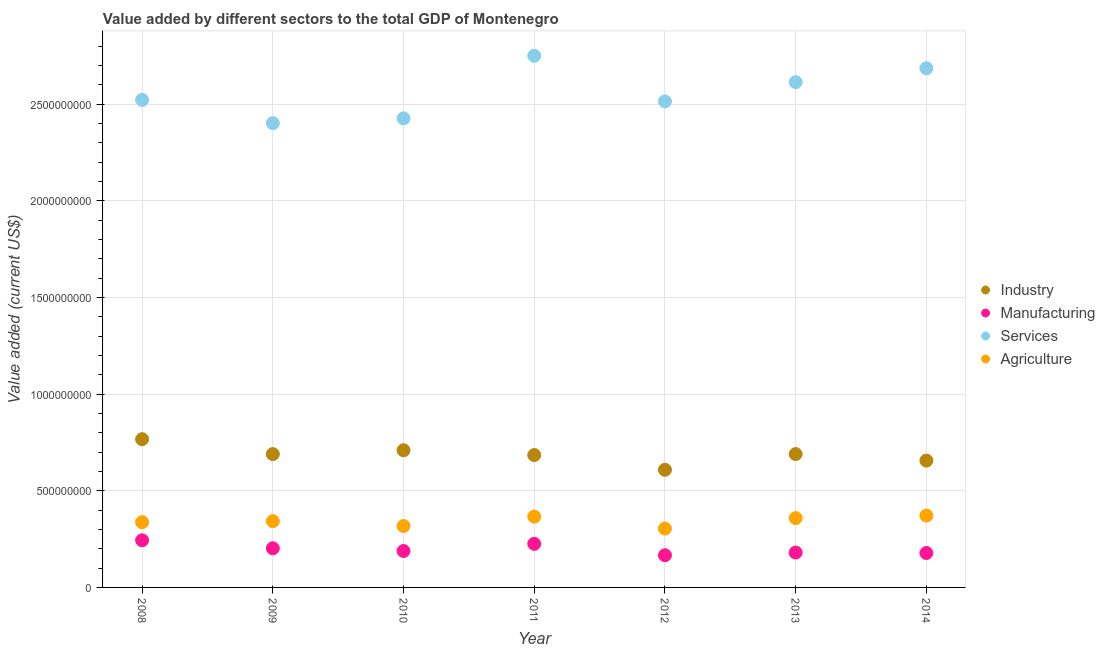How many different coloured dotlines are there?
Ensure brevity in your answer.  4. What is the value added by services sector in 2014?
Make the answer very short. 2.69e+09. Across all years, what is the maximum value added by industrial sector?
Ensure brevity in your answer.  7.67e+08. Across all years, what is the minimum value added by agricultural sector?
Your response must be concise. 3.05e+08. In which year was the value added by industrial sector maximum?
Provide a succinct answer. 2008. What is the total value added by services sector in the graph?
Ensure brevity in your answer.  1.79e+1. What is the difference between the value added by agricultural sector in 2009 and that in 2014?
Make the answer very short. -2.87e+07. What is the difference between the value added by manufacturing sector in 2014 and the value added by industrial sector in 2008?
Provide a short and direct response. -5.89e+08. What is the average value added by manufacturing sector per year?
Keep it short and to the point. 1.98e+08. In the year 2008, what is the difference between the value added by manufacturing sector and value added by industrial sector?
Your answer should be compact. -5.23e+08. In how many years, is the value added by services sector greater than 100000000 US$?
Provide a short and direct response. 7. What is the ratio of the value added by services sector in 2013 to that in 2014?
Offer a terse response. 0.97. What is the difference between the highest and the second highest value added by services sector?
Offer a very short reply. 6.45e+07. What is the difference between the highest and the lowest value added by industrial sector?
Provide a succinct answer. 1.59e+08. In how many years, is the value added by agricultural sector greater than the average value added by agricultural sector taken over all years?
Give a very brief answer. 4. Is the sum of the value added by services sector in 2008 and 2012 greater than the maximum value added by agricultural sector across all years?
Provide a short and direct response. Yes. Is it the case that in every year, the sum of the value added by industrial sector and value added by manufacturing sector is greater than the value added by services sector?
Your answer should be very brief. No. Does the value added by services sector monotonically increase over the years?
Make the answer very short. No. How many years are there in the graph?
Offer a terse response. 7. Does the graph contain grids?
Offer a very short reply. Yes. How many legend labels are there?
Provide a succinct answer. 4. How are the legend labels stacked?
Offer a very short reply. Vertical. What is the title of the graph?
Offer a terse response. Value added by different sectors to the total GDP of Montenegro. What is the label or title of the Y-axis?
Ensure brevity in your answer.  Value added (current US$). What is the Value added (current US$) of Industry in 2008?
Keep it short and to the point. 7.67e+08. What is the Value added (current US$) of Manufacturing in 2008?
Offer a terse response. 2.44e+08. What is the Value added (current US$) in Services in 2008?
Offer a very short reply. 2.52e+09. What is the Value added (current US$) of Agriculture in 2008?
Provide a succinct answer. 3.38e+08. What is the Value added (current US$) of Industry in 2009?
Offer a terse response. 6.90e+08. What is the Value added (current US$) of Manufacturing in 2009?
Offer a very short reply. 2.03e+08. What is the Value added (current US$) of Services in 2009?
Your answer should be compact. 2.40e+09. What is the Value added (current US$) in Agriculture in 2009?
Your answer should be very brief. 3.43e+08. What is the Value added (current US$) in Industry in 2010?
Offer a terse response. 7.10e+08. What is the Value added (current US$) of Manufacturing in 2010?
Ensure brevity in your answer.  1.88e+08. What is the Value added (current US$) in Services in 2010?
Offer a terse response. 2.43e+09. What is the Value added (current US$) in Agriculture in 2010?
Offer a very short reply. 3.18e+08. What is the Value added (current US$) of Industry in 2011?
Ensure brevity in your answer.  6.85e+08. What is the Value added (current US$) in Manufacturing in 2011?
Your answer should be compact. 2.26e+08. What is the Value added (current US$) of Services in 2011?
Keep it short and to the point. 2.75e+09. What is the Value added (current US$) of Agriculture in 2011?
Provide a short and direct response. 3.66e+08. What is the Value added (current US$) of Industry in 2012?
Your answer should be compact. 6.09e+08. What is the Value added (current US$) of Manufacturing in 2012?
Keep it short and to the point. 1.67e+08. What is the Value added (current US$) of Services in 2012?
Ensure brevity in your answer.  2.51e+09. What is the Value added (current US$) in Agriculture in 2012?
Provide a succinct answer. 3.05e+08. What is the Value added (current US$) of Industry in 2013?
Your response must be concise. 6.90e+08. What is the Value added (current US$) of Manufacturing in 2013?
Your answer should be very brief. 1.80e+08. What is the Value added (current US$) in Services in 2013?
Keep it short and to the point. 2.61e+09. What is the Value added (current US$) of Agriculture in 2013?
Provide a succinct answer. 3.59e+08. What is the Value added (current US$) of Industry in 2014?
Give a very brief answer. 6.56e+08. What is the Value added (current US$) of Manufacturing in 2014?
Your answer should be compact. 1.78e+08. What is the Value added (current US$) in Services in 2014?
Your answer should be very brief. 2.69e+09. What is the Value added (current US$) of Agriculture in 2014?
Your response must be concise. 3.72e+08. Across all years, what is the maximum Value added (current US$) of Industry?
Ensure brevity in your answer.  7.67e+08. Across all years, what is the maximum Value added (current US$) of Manufacturing?
Your answer should be compact. 2.44e+08. Across all years, what is the maximum Value added (current US$) of Services?
Make the answer very short. 2.75e+09. Across all years, what is the maximum Value added (current US$) of Agriculture?
Provide a short and direct response. 3.72e+08. Across all years, what is the minimum Value added (current US$) in Industry?
Provide a short and direct response. 6.09e+08. Across all years, what is the minimum Value added (current US$) in Manufacturing?
Offer a very short reply. 1.67e+08. Across all years, what is the minimum Value added (current US$) in Services?
Keep it short and to the point. 2.40e+09. Across all years, what is the minimum Value added (current US$) in Agriculture?
Your answer should be compact. 3.05e+08. What is the total Value added (current US$) of Industry in the graph?
Provide a short and direct response. 4.81e+09. What is the total Value added (current US$) in Manufacturing in the graph?
Offer a terse response. 1.39e+09. What is the total Value added (current US$) in Services in the graph?
Offer a terse response. 1.79e+1. What is the total Value added (current US$) in Agriculture in the graph?
Your response must be concise. 2.40e+09. What is the difference between the Value added (current US$) of Industry in 2008 and that in 2009?
Keep it short and to the point. 7.74e+07. What is the difference between the Value added (current US$) of Manufacturing in 2008 and that in 2009?
Give a very brief answer. 4.13e+07. What is the difference between the Value added (current US$) in Services in 2008 and that in 2009?
Ensure brevity in your answer.  1.20e+08. What is the difference between the Value added (current US$) of Agriculture in 2008 and that in 2009?
Ensure brevity in your answer.  -5.26e+06. What is the difference between the Value added (current US$) in Industry in 2008 and that in 2010?
Keep it short and to the point. 5.74e+07. What is the difference between the Value added (current US$) of Manufacturing in 2008 and that in 2010?
Your response must be concise. 5.54e+07. What is the difference between the Value added (current US$) in Services in 2008 and that in 2010?
Offer a terse response. 9.55e+07. What is the difference between the Value added (current US$) in Agriculture in 2008 and that in 2010?
Your answer should be very brief. 1.98e+07. What is the difference between the Value added (current US$) in Industry in 2008 and that in 2011?
Your response must be concise. 8.22e+07. What is the difference between the Value added (current US$) of Manufacturing in 2008 and that in 2011?
Give a very brief answer. 1.82e+07. What is the difference between the Value added (current US$) in Services in 2008 and that in 2011?
Ensure brevity in your answer.  -2.28e+08. What is the difference between the Value added (current US$) in Agriculture in 2008 and that in 2011?
Offer a terse response. -2.87e+07. What is the difference between the Value added (current US$) in Industry in 2008 and that in 2012?
Ensure brevity in your answer.  1.59e+08. What is the difference between the Value added (current US$) of Manufacturing in 2008 and that in 2012?
Your answer should be compact. 7.72e+07. What is the difference between the Value added (current US$) of Services in 2008 and that in 2012?
Your answer should be very brief. 7.86e+06. What is the difference between the Value added (current US$) in Agriculture in 2008 and that in 2012?
Your answer should be very brief. 3.30e+07. What is the difference between the Value added (current US$) in Industry in 2008 and that in 2013?
Offer a very short reply. 7.71e+07. What is the difference between the Value added (current US$) of Manufacturing in 2008 and that in 2013?
Make the answer very short. 6.33e+07. What is the difference between the Value added (current US$) in Services in 2008 and that in 2013?
Keep it short and to the point. -9.17e+07. What is the difference between the Value added (current US$) in Agriculture in 2008 and that in 2013?
Make the answer very short. -2.11e+07. What is the difference between the Value added (current US$) in Industry in 2008 and that in 2014?
Your answer should be very brief. 1.11e+08. What is the difference between the Value added (current US$) in Manufacturing in 2008 and that in 2014?
Offer a terse response. 6.58e+07. What is the difference between the Value added (current US$) in Services in 2008 and that in 2014?
Provide a succinct answer. -1.64e+08. What is the difference between the Value added (current US$) of Agriculture in 2008 and that in 2014?
Your answer should be compact. -3.40e+07. What is the difference between the Value added (current US$) of Industry in 2009 and that in 2010?
Ensure brevity in your answer.  -2.00e+07. What is the difference between the Value added (current US$) of Manufacturing in 2009 and that in 2010?
Provide a short and direct response. 1.41e+07. What is the difference between the Value added (current US$) in Services in 2009 and that in 2010?
Give a very brief answer. -2.50e+07. What is the difference between the Value added (current US$) in Agriculture in 2009 and that in 2010?
Provide a succinct answer. 2.51e+07. What is the difference between the Value added (current US$) in Industry in 2009 and that in 2011?
Your answer should be compact. 4.80e+06. What is the difference between the Value added (current US$) of Manufacturing in 2009 and that in 2011?
Your answer should be compact. -2.31e+07. What is the difference between the Value added (current US$) of Services in 2009 and that in 2011?
Offer a terse response. -3.49e+08. What is the difference between the Value added (current US$) of Agriculture in 2009 and that in 2011?
Provide a succinct answer. -2.35e+07. What is the difference between the Value added (current US$) in Industry in 2009 and that in 2012?
Provide a succinct answer. 8.11e+07. What is the difference between the Value added (current US$) of Manufacturing in 2009 and that in 2012?
Your answer should be compact. 3.59e+07. What is the difference between the Value added (current US$) of Services in 2009 and that in 2012?
Make the answer very short. -1.13e+08. What is the difference between the Value added (current US$) in Agriculture in 2009 and that in 2012?
Provide a succinct answer. 3.83e+07. What is the difference between the Value added (current US$) in Industry in 2009 and that in 2013?
Offer a terse response. -2.49e+05. What is the difference between the Value added (current US$) in Manufacturing in 2009 and that in 2013?
Offer a terse response. 2.21e+07. What is the difference between the Value added (current US$) of Services in 2009 and that in 2013?
Make the answer very short. -2.12e+08. What is the difference between the Value added (current US$) in Agriculture in 2009 and that in 2013?
Provide a short and direct response. -1.58e+07. What is the difference between the Value added (current US$) of Industry in 2009 and that in 2014?
Offer a terse response. 3.36e+07. What is the difference between the Value added (current US$) in Manufacturing in 2009 and that in 2014?
Make the answer very short. 2.45e+07. What is the difference between the Value added (current US$) in Services in 2009 and that in 2014?
Your answer should be compact. -2.84e+08. What is the difference between the Value added (current US$) in Agriculture in 2009 and that in 2014?
Give a very brief answer. -2.87e+07. What is the difference between the Value added (current US$) of Industry in 2010 and that in 2011?
Keep it short and to the point. 2.48e+07. What is the difference between the Value added (current US$) of Manufacturing in 2010 and that in 2011?
Your answer should be compact. -3.72e+07. What is the difference between the Value added (current US$) of Services in 2010 and that in 2011?
Make the answer very short. -3.24e+08. What is the difference between the Value added (current US$) of Agriculture in 2010 and that in 2011?
Give a very brief answer. -4.86e+07. What is the difference between the Value added (current US$) in Industry in 2010 and that in 2012?
Make the answer very short. 1.01e+08. What is the difference between the Value added (current US$) of Manufacturing in 2010 and that in 2012?
Your answer should be compact. 2.18e+07. What is the difference between the Value added (current US$) of Services in 2010 and that in 2012?
Provide a succinct answer. -8.77e+07. What is the difference between the Value added (current US$) in Agriculture in 2010 and that in 2012?
Provide a short and direct response. 1.32e+07. What is the difference between the Value added (current US$) of Industry in 2010 and that in 2013?
Your answer should be compact. 1.98e+07. What is the difference between the Value added (current US$) of Manufacturing in 2010 and that in 2013?
Offer a very short reply. 7.96e+06. What is the difference between the Value added (current US$) in Services in 2010 and that in 2013?
Give a very brief answer. -1.87e+08. What is the difference between the Value added (current US$) of Agriculture in 2010 and that in 2013?
Ensure brevity in your answer.  -4.09e+07. What is the difference between the Value added (current US$) in Industry in 2010 and that in 2014?
Provide a succinct answer. 5.36e+07. What is the difference between the Value added (current US$) in Manufacturing in 2010 and that in 2014?
Offer a terse response. 1.04e+07. What is the difference between the Value added (current US$) in Services in 2010 and that in 2014?
Give a very brief answer. -2.59e+08. What is the difference between the Value added (current US$) in Agriculture in 2010 and that in 2014?
Make the answer very short. -5.38e+07. What is the difference between the Value added (current US$) in Industry in 2011 and that in 2012?
Your answer should be compact. 7.63e+07. What is the difference between the Value added (current US$) in Manufacturing in 2011 and that in 2012?
Make the answer very short. 5.90e+07. What is the difference between the Value added (current US$) in Services in 2011 and that in 2012?
Provide a succinct answer. 2.36e+08. What is the difference between the Value added (current US$) in Agriculture in 2011 and that in 2012?
Provide a succinct answer. 6.17e+07. What is the difference between the Value added (current US$) in Industry in 2011 and that in 2013?
Provide a succinct answer. -5.05e+06. What is the difference between the Value added (current US$) of Manufacturing in 2011 and that in 2013?
Keep it short and to the point. 4.51e+07. What is the difference between the Value added (current US$) in Services in 2011 and that in 2013?
Make the answer very short. 1.36e+08. What is the difference between the Value added (current US$) in Agriculture in 2011 and that in 2013?
Ensure brevity in your answer.  7.68e+06. What is the difference between the Value added (current US$) of Industry in 2011 and that in 2014?
Your answer should be compact. 2.88e+07. What is the difference between the Value added (current US$) in Manufacturing in 2011 and that in 2014?
Keep it short and to the point. 4.76e+07. What is the difference between the Value added (current US$) in Services in 2011 and that in 2014?
Offer a terse response. 6.45e+07. What is the difference between the Value added (current US$) in Agriculture in 2011 and that in 2014?
Provide a succinct answer. -5.25e+06. What is the difference between the Value added (current US$) of Industry in 2012 and that in 2013?
Ensure brevity in your answer.  -8.14e+07. What is the difference between the Value added (current US$) in Manufacturing in 2012 and that in 2013?
Keep it short and to the point. -1.39e+07. What is the difference between the Value added (current US$) in Services in 2012 and that in 2013?
Give a very brief answer. -9.96e+07. What is the difference between the Value added (current US$) of Agriculture in 2012 and that in 2013?
Your answer should be very brief. -5.41e+07. What is the difference between the Value added (current US$) of Industry in 2012 and that in 2014?
Your response must be concise. -4.76e+07. What is the difference between the Value added (current US$) in Manufacturing in 2012 and that in 2014?
Your answer should be compact. -1.14e+07. What is the difference between the Value added (current US$) of Services in 2012 and that in 2014?
Give a very brief answer. -1.71e+08. What is the difference between the Value added (current US$) in Agriculture in 2012 and that in 2014?
Provide a succinct answer. -6.70e+07. What is the difference between the Value added (current US$) of Industry in 2013 and that in 2014?
Make the answer very short. 3.38e+07. What is the difference between the Value added (current US$) of Manufacturing in 2013 and that in 2014?
Offer a terse response. 2.48e+06. What is the difference between the Value added (current US$) of Services in 2013 and that in 2014?
Give a very brief answer. -7.19e+07. What is the difference between the Value added (current US$) in Agriculture in 2013 and that in 2014?
Offer a terse response. -1.29e+07. What is the difference between the Value added (current US$) in Industry in 2008 and the Value added (current US$) in Manufacturing in 2009?
Provide a short and direct response. 5.65e+08. What is the difference between the Value added (current US$) in Industry in 2008 and the Value added (current US$) in Services in 2009?
Your answer should be compact. -1.64e+09. What is the difference between the Value added (current US$) in Industry in 2008 and the Value added (current US$) in Agriculture in 2009?
Give a very brief answer. 4.24e+08. What is the difference between the Value added (current US$) of Manufacturing in 2008 and the Value added (current US$) of Services in 2009?
Offer a terse response. -2.16e+09. What is the difference between the Value added (current US$) of Manufacturing in 2008 and the Value added (current US$) of Agriculture in 2009?
Your answer should be very brief. -9.90e+07. What is the difference between the Value added (current US$) in Services in 2008 and the Value added (current US$) in Agriculture in 2009?
Ensure brevity in your answer.  2.18e+09. What is the difference between the Value added (current US$) of Industry in 2008 and the Value added (current US$) of Manufacturing in 2010?
Your answer should be very brief. 5.79e+08. What is the difference between the Value added (current US$) in Industry in 2008 and the Value added (current US$) in Services in 2010?
Ensure brevity in your answer.  -1.66e+09. What is the difference between the Value added (current US$) of Industry in 2008 and the Value added (current US$) of Agriculture in 2010?
Keep it short and to the point. 4.49e+08. What is the difference between the Value added (current US$) of Manufacturing in 2008 and the Value added (current US$) of Services in 2010?
Provide a short and direct response. -2.18e+09. What is the difference between the Value added (current US$) of Manufacturing in 2008 and the Value added (current US$) of Agriculture in 2010?
Provide a succinct answer. -7.40e+07. What is the difference between the Value added (current US$) in Services in 2008 and the Value added (current US$) in Agriculture in 2010?
Offer a very short reply. 2.21e+09. What is the difference between the Value added (current US$) of Industry in 2008 and the Value added (current US$) of Manufacturing in 2011?
Provide a succinct answer. 5.42e+08. What is the difference between the Value added (current US$) of Industry in 2008 and the Value added (current US$) of Services in 2011?
Keep it short and to the point. -1.98e+09. What is the difference between the Value added (current US$) in Industry in 2008 and the Value added (current US$) in Agriculture in 2011?
Keep it short and to the point. 4.01e+08. What is the difference between the Value added (current US$) in Manufacturing in 2008 and the Value added (current US$) in Services in 2011?
Ensure brevity in your answer.  -2.51e+09. What is the difference between the Value added (current US$) in Manufacturing in 2008 and the Value added (current US$) in Agriculture in 2011?
Offer a very short reply. -1.23e+08. What is the difference between the Value added (current US$) of Services in 2008 and the Value added (current US$) of Agriculture in 2011?
Ensure brevity in your answer.  2.16e+09. What is the difference between the Value added (current US$) of Industry in 2008 and the Value added (current US$) of Manufacturing in 2012?
Keep it short and to the point. 6.01e+08. What is the difference between the Value added (current US$) in Industry in 2008 and the Value added (current US$) in Services in 2012?
Ensure brevity in your answer.  -1.75e+09. What is the difference between the Value added (current US$) in Industry in 2008 and the Value added (current US$) in Agriculture in 2012?
Make the answer very short. 4.63e+08. What is the difference between the Value added (current US$) of Manufacturing in 2008 and the Value added (current US$) of Services in 2012?
Provide a succinct answer. -2.27e+09. What is the difference between the Value added (current US$) in Manufacturing in 2008 and the Value added (current US$) in Agriculture in 2012?
Your response must be concise. -6.08e+07. What is the difference between the Value added (current US$) in Services in 2008 and the Value added (current US$) in Agriculture in 2012?
Your answer should be very brief. 2.22e+09. What is the difference between the Value added (current US$) of Industry in 2008 and the Value added (current US$) of Manufacturing in 2013?
Ensure brevity in your answer.  5.87e+08. What is the difference between the Value added (current US$) of Industry in 2008 and the Value added (current US$) of Services in 2013?
Make the answer very short. -1.85e+09. What is the difference between the Value added (current US$) of Industry in 2008 and the Value added (current US$) of Agriculture in 2013?
Keep it short and to the point. 4.09e+08. What is the difference between the Value added (current US$) of Manufacturing in 2008 and the Value added (current US$) of Services in 2013?
Your response must be concise. -2.37e+09. What is the difference between the Value added (current US$) in Manufacturing in 2008 and the Value added (current US$) in Agriculture in 2013?
Provide a short and direct response. -1.15e+08. What is the difference between the Value added (current US$) in Services in 2008 and the Value added (current US$) in Agriculture in 2013?
Keep it short and to the point. 2.16e+09. What is the difference between the Value added (current US$) of Industry in 2008 and the Value added (current US$) of Manufacturing in 2014?
Your answer should be compact. 5.89e+08. What is the difference between the Value added (current US$) of Industry in 2008 and the Value added (current US$) of Services in 2014?
Offer a very short reply. -1.92e+09. What is the difference between the Value added (current US$) of Industry in 2008 and the Value added (current US$) of Agriculture in 2014?
Provide a short and direct response. 3.96e+08. What is the difference between the Value added (current US$) of Manufacturing in 2008 and the Value added (current US$) of Services in 2014?
Offer a very short reply. -2.44e+09. What is the difference between the Value added (current US$) of Manufacturing in 2008 and the Value added (current US$) of Agriculture in 2014?
Your answer should be very brief. -1.28e+08. What is the difference between the Value added (current US$) in Services in 2008 and the Value added (current US$) in Agriculture in 2014?
Provide a short and direct response. 2.15e+09. What is the difference between the Value added (current US$) of Industry in 2009 and the Value added (current US$) of Manufacturing in 2010?
Make the answer very short. 5.01e+08. What is the difference between the Value added (current US$) of Industry in 2009 and the Value added (current US$) of Services in 2010?
Keep it short and to the point. -1.74e+09. What is the difference between the Value added (current US$) in Industry in 2009 and the Value added (current US$) in Agriculture in 2010?
Offer a terse response. 3.72e+08. What is the difference between the Value added (current US$) in Manufacturing in 2009 and the Value added (current US$) in Services in 2010?
Provide a succinct answer. -2.22e+09. What is the difference between the Value added (current US$) in Manufacturing in 2009 and the Value added (current US$) in Agriculture in 2010?
Your answer should be very brief. -1.15e+08. What is the difference between the Value added (current US$) in Services in 2009 and the Value added (current US$) in Agriculture in 2010?
Keep it short and to the point. 2.08e+09. What is the difference between the Value added (current US$) in Industry in 2009 and the Value added (current US$) in Manufacturing in 2011?
Give a very brief answer. 4.64e+08. What is the difference between the Value added (current US$) of Industry in 2009 and the Value added (current US$) of Services in 2011?
Provide a succinct answer. -2.06e+09. What is the difference between the Value added (current US$) in Industry in 2009 and the Value added (current US$) in Agriculture in 2011?
Keep it short and to the point. 3.23e+08. What is the difference between the Value added (current US$) in Manufacturing in 2009 and the Value added (current US$) in Services in 2011?
Offer a very short reply. -2.55e+09. What is the difference between the Value added (current US$) of Manufacturing in 2009 and the Value added (current US$) of Agriculture in 2011?
Keep it short and to the point. -1.64e+08. What is the difference between the Value added (current US$) of Services in 2009 and the Value added (current US$) of Agriculture in 2011?
Your answer should be compact. 2.04e+09. What is the difference between the Value added (current US$) in Industry in 2009 and the Value added (current US$) in Manufacturing in 2012?
Provide a short and direct response. 5.23e+08. What is the difference between the Value added (current US$) in Industry in 2009 and the Value added (current US$) in Services in 2012?
Make the answer very short. -1.83e+09. What is the difference between the Value added (current US$) in Industry in 2009 and the Value added (current US$) in Agriculture in 2012?
Your answer should be compact. 3.85e+08. What is the difference between the Value added (current US$) in Manufacturing in 2009 and the Value added (current US$) in Services in 2012?
Offer a terse response. -2.31e+09. What is the difference between the Value added (current US$) of Manufacturing in 2009 and the Value added (current US$) of Agriculture in 2012?
Give a very brief answer. -1.02e+08. What is the difference between the Value added (current US$) of Services in 2009 and the Value added (current US$) of Agriculture in 2012?
Your response must be concise. 2.10e+09. What is the difference between the Value added (current US$) of Industry in 2009 and the Value added (current US$) of Manufacturing in 2013?
Offer a very short reply. 5.09e+08. What is the difference between the Value added (current US$) of Industry in 2009 and the Value added (current US$) of Services in 2013?
Your response must be concise. -1.92e+09. What is the difference between the Value added (current US$) of Industry in 2009 and the Value added (current US$) of Agriculture in 2013?
Your answer should be very brief. 3.31e+08. What is the difference between the Value added (current US$) in Manufacturing in 2009 and the Value added (current US$) in Services in 2013?
Make the answer very short. -2.41e+09. What is the difference between the Value added (current US$) in Manufacturing in 2009 and the Value added (current US$) in Agriculture in 2013?
Provide a succinct answer. -1.56e+08. What is the difference between the Value added (current US$) of Services in 2009 and the Value added (current US$) of Agriculture in 2013?
Your response must be concise. 2.04e+09. What is the difference between the Value added (current US$) in Industry in 2009 and the Value added (current US$) in Manufacturing in 2014?
Give a very brief answer. 5.12e+08. What is the difference between the Value added (current US$) of Industry in 2009 and the Value added (current US$) of Services in 2014?
Give a very brief answer. -2.00e+09. What is the difference between the Value added (current US$) of Industry in 2009 and the Value added (current US$) of Agriculture in 2014?
Ensure brevity in your answer.  3.18e+08. What is the difference between the Value added (current US$) in Manufacturing in 2009 and the Value added (current US$) in Services in 2014?
Ensure brevity in your answer.  -2.48e+09. What is the difference between the Value added (current US$) of Manufacturing in 2009 and the Value added (current US$) of Agriculture in 2014?
Offer a terse response. -1.69e+08. What is the difference between the Value added (current US$) of Services in 2009 and the Value added (current US$) of Agriculture in 2014?
Your answer should be compact. 2.03e+09. What is the difference between the Value added (current US$) of Industry in 2010 and the Value added (current US$) of Manufacturing in 2011?
Give a very brief answer. 4.84e+08. What is the difference between the Value added (current US$) in Industry in 2010 and the Value added (current US$) in Services in 2011?
Offer a terse response. -2.04e+09. What is the difference between the Value added (current US$) of Industry in 2010 and the Value added (current US$) of Agriculture in 2011?
Offer a terse response. 3.43e+08. What is the difference between the Value added (current US$) of Manufacturing in 2010 and the Value added (current US$) of Services in 2011?
Your answer should be very brief. -2.56e+09. What is the difference between the Value added (current US$) in Manufacturing in 2010 and the Value added (current US$) in Agriculture in 2011?
Your answer should be very brief. -1.78e+08. What is the difference between the Value added (current US$) of Services in 2010 and the Value added (current US$) of Agriculture in 2011?
Make the answer very short. 2.06e+09. What is the difference between the Value added (current US$) of Industry in 2010 and the Value added (current US$) of Manufacturing in 2012?
Your answer should be compact. 5.43e+08. What is the difference between the Value added (current US$) in Industry in 2010 and the Value added (current US$) in Services in 2012?
Ensure brevity in your answer.  -1.81e+09. What is the difference between the Value added (current US$) of Industry in 2010 and the Value added (current US$) of Agriculture in 2012?
Your answer should be very brief. 4.05e+08. What is the difference between the Value added (current US$) in Manufacturing in 2010 and the Value added (current US$) in Services in 2012?
Give a very brief answer. -2.33e+09. What is the difference between the Value added (current US$) in Manufacturing in 2010 and the Value added (current US$) in Agriculture in 2012?
Ensure brevity in your answer.  -1.16e+08. What is the difference between the Value added (current US$) in Services in 2010 and the Value added (current US$) in Agriculture in 2012?
Offer a terse response. 2.12e+09. What is the difference between the Value added (current US$) of Industry in 2010 and the Value added (current US$) of Manufacturing in 2013?
Offer a terse response. 5.29e+08. What is the difference between the Value added (current US$) of Industry in 2010 and the Value added (current US$) of Services in 2013?
Give a very brief answer. -1.90e+09. What is the difference between the Value added (current US$) in Industry in 2010 and the Value added (current US$) in Agriculture in 2013?
Ensure brevity in your answer.  3.51e+08. What is the difference between the Value added (current US$) of Manufacturing in 2010 and the Value added (current US$) of Services in 2013?
Offer a very short reply. -2.43e+09. What is the difference between the Value added (current US$) in Manufacturing in 2010 and the Value added (current US$) in Agriculture in 2013?
Your answer should be very brief. -1.70e+08. What is the difference between the Value added (current US$) of Services in 2010 and the Value added (current US$) of Agriculture in 2013?
Ensure brevity in your answer.  2.07e+09. What is the difference between the Value added (current US$) in Industry in 2010 and the Value added (current US$) in Manufacturing in 2014?
Your answer should be compact. 5.32e+08. What is the difference between the Value added (current US$) in Industry in 2010 and the Value added (current US$) in Services in 2014?
Provide a short and direct response. -1.98e+09. What is the difference between the Value added (current US$) in Industry in 2010 and the Value added (current US$) in Agriculture in 2014?
Make the answer very short. 3.38e+08. What is the difference between the Value added (current US$) in Manufacturing in 2010 and the Value added (current US$) in Services in 2014?
Your answer should be very brief. -2.50e+09. What is the difference between the Value added (current US$) of Manufacturing in 2010 and the Value added (current US$) of Agriculture in 2014?
Give a very brief answer. -1.83e+08. What is the difference between the Value added (current US$) in Services in 2010 and the Value added (current US$) in Agriculture in 2014?
Make the answer very short. 2.06e+09. What is the difference between the Value added (current US$) in Industry in 2011 and the Value added (current US$) in Manufacturing in 2012?
Your answer should be very brief. 5.18e+08. What is the difference between the Value added (current US$) in Industry in 2011 and the Value added (current US$) in Services in 2012?
Keep it short and to the point. -1.83e+09. What is the difference between the Value added (current US$) of Industry in 2011 and the Value added (current US$) of Agriculture in 2012?
Offer a terse response. 3.80e+08. What is the difference between the Value added (current US$) in Manufacturing in 2011 and the Value added (current US$) in Services in 2012?
Give a very brief answer. -2.29e+09. What is the difference between the Value added (current US$) in Manufacturing in 2011 and the Value added (current US$) in Agriculture in 2012?
Provide a succinct answer. -7.90e+07. What is the difference between the Value added (current US$) in Services in 2011 and the Value added (current US$) in Agriculture in 2012?
Offer a very short reply. 2.45e+09. What is the difference between the Value added (current US$) in Industry in 2011 and the Value added (current US$) in Manufacturing in 2013?
Provide a succinct answer. 5.05e+08. What is the difference between the Value added (current US$) in Industry in 2011 and the Value added (current US$) in Services in 2013?
Make the answer very short. -1.93e+09. What is the difference between the Value added (current US$) of Industry in 2011 and the Value added (current US$) of Agriculture in 2013?
Keep it short and to the point. 3.26e+08. What is the difference between the Value added (current US$) in Manufacturing in 2011 and the Value added (current US$) in Services in 2013?
Make the answer very short. -2.39e+09. What is the difference between the Value added (current US$) in Manufacturing in 2011 and the Value added (current US$) in Agriculture in 2013?
Your response must be concise. -1.33e+08. What is the difference between the Value added (current US$) in Services in 2011 and the Value added (current US$) in Agriculture in 2013?
Provide a succinct answer. 2.39e+09. What is the difference between the Value added (current US$) in Industry in 2011 and the Value added (current US$) in Manufacturing in 2014?
Ensure brevity in your answer.  5.07e+08. What is the difference between the Value added (current US$) in Industry in 2011 and the Value added (current US$) in Services in 2014?
Your response must be concise. -2.00e+09. What is the difference between the Value added (current US$) in Industry in 2011 and the Value added (current US$) in Agriculture in 2014?
Make the answer very short. 3.13e+08. What is the difference between the Value added (current US$) of Manufacturing in 2011 and the Value added (current US$) of Services in 2014?
Ensure brevity in your answer.  -2.46e+09. What is the difference between the Value added (current US$) of Manufacturing in 2011 and the Value added (current US$) of Agriculture in 2014?
Provide a short and direct response. -1.46e+08. What is the difference between the Value added (current US$) in Services in 2011 and the Value added (current US$) in Agriculture in 2014?
Offer a very short reply. 2.38e+09. What is the difference between the Value added (current US$) in Industry in 2012 and the Value added (current US$) in Manufacturing in 2013?
Your answer should be compact. 4.28e+08. What is the difference between the Value added (current US$) of Industry in 2012 and the Value added (current US$) of Services in 2013?
Your answer should be very brief. -2.01e+09. What is the difference between the Value added (current US$) in Industry in 2012 and the Value added (current US$) in Agriculture in 2013?
Your response must be concise. 2.50e+08. What is the difference between the Value added (current US$) in Manufacturing in 2012 and the Value added (current US$) in Services in 2013?
Keep it short and to the point. -2.45e+09. What is the difference between the Value added (current US$) of Manufacturing in 2012 and the Value added (current US$) of Agriculture in 2013?
Ensure brevity in your answer.  -1.92e+08. What is the difference between the Value added (current US$) in Services in 2012 and the Value added (current US$) in Agriculture in 2013?
Give a very brief answer. 2.16e+09. What is the difference between the Value added (current US$) of Industry in 2012 and the Value added (current US$) of Manufacturing in 2014?
Make the answer very short. 4.31e+08. What is the difference between the Value added (current US$) in Industry in 2012 and the Value added (current US$) in Services in 2014?
Provide a succinct answer. -2.08e+09. What is the difference between the Value added (current US$) in Industry in 2012 and the Value added (current US$) in Agriculture in 2014?
Ensure brevity in your answer.  2.37e+08. What is the difference between the Value added (current US$) of Manufacturing in 2012 and the Value added (current US$) of Services in 2014?
Give a very brief answer. -2.52e+09. What is the difference between the Value added (current US$) of Manufacturing in 2012 and the Value added (current US$) of Agriculture in 2014?
Offer a terse response. -2.05e+08. What is the difference between the Value added (current US$) in Services in 2012 and the Value added (current US$) in Agriculture in 2014?
Your answer should be very brief. 2.14e+09. What is the difference between the Value added (current US$) in Industry in 2013 and the Value added (current US$) in Manufacturing in 2014?
Provide a succinct answer. 5.12e+08. What is the difference between the Value added (current US$) of Industry in 2013 and the Value added (current US$) of Services in 2014?
Offer a very short reply. -2.00e+09. What is the difference between the Value added (current US$) in Industry in 2013 and the Value added (current US$) in Agriculture in 2014?
Give a very brief answer. 3.18e+08. What is the difference between the Value added (current US$) in Manufacturing in 2013 and the Value added (current US$) in Services in 2014?
Give a very brief answer. -2.51e+09. What is the difference between the Value added (current US$) of Manufacturing in 2013 and the Value added (current US$) of Agriculture in 2014?
Make the answer very short. -1.91e+08. What is the difference between the Value added (current US$) of Services in 2013 and the Value added (current US$) of Agriculture in 2014?
Your answer should be very brief. 2.24e+09. What is the average Value added (current US$) of Industry per year?
Provide a succinct answer. 6.87e+08. What is the average Value added (current US$) of Manufacturing per year?
Provide a short and direct response. 1.98e+08. What is the average Value added (current US$) in Services per year?
Offer a very short reply. 2.56e+09. What is the average Value added (current US$) in Agriculture per year?
Provide a succinct answer. 3.43e+08. In the year 2008, what is the difference between the Value added (current US$) in Industry and Value added (current US$) in Manufacturing?
Your response must be concise. 5.23e+08. In the year 2008, what is the difference between the Value added (current US$) in Industry and Value added (current US$) in Services?
Offer a very short reply. -1.76e+09. In the year 2008, what is the difference between the Value added (current US$) of Industry and Value added (current US$) of Agriculture?
Your answer should be compact. 4.30e+08. In the year 2008, what is the difference between the Value added (current US$) of Manufacturing and Value added (current US$) of Services?
Provide a short and direct response. -2.28e+09. In the year 2008, what is the difference between the Value added (current US$) of Manufacturing and Value added (current US$) of Agriculture?
Your response must be concise. -9.38e+07. In the year 2008, what is the difference between the Value added (current US$) of Services and Value added (current US$) of Agriculture?
Your response must be concise. 2.19e+09. In the year 2009, what is the difference between the Value added (current US$) in Industry and Value added (current US$) in Manufacturing?
Your response must be concise. 4.87e+08. In the year 2009, what is the difference between the Value added (current US$) in Industry and Value added (current US$) in Services?
Keep it short and to the point. -1.71e+09. In the year 2009, what is the difference between the Value added (current US$) in Industry and Value added (current US$) in Agriculture?
Offer a terse response. 3.47e+08. In the year 2009, what is the difference between the Value added (current US$) in Manufacturing and Value added (current US$) in Services?
Your response must be concise. -2.20e+09. In the year 2009, what is the difference between the Value added (current US$) in Manufacturing and Value added (current US$) in Agriculture?
Make the answer very short. -1.40e+08. In the year 2009, what is the difference between the Value added (current US$) in Services and Value added (current US$) in Agriculture?
Ensure brevity in your answer.  2.06e+09. In the year 2010, what is the difference between the Value added (current US$) of Industry and Value added (current US$) of Manufacturing?
Your answer should be very brief. 5.21e+08. In the year 2010, what is the difference between the Value added (current US$) in Industry and Value added (current US$) in Services?
Provide a succinct answer. -1.72e+09. In the year 2010, what is the difference between the Value added (current US$) of Industry and Value added (current US$) of Agriculture?
Ensure brevity in your answer.  3.92e+08. In the year 2010, what is the difference between the Value added (current US$) of Manufacturing and Value added (current US$) of Services?
Make the answer very short. -2.24e+09. In the year 2010, what is the difference between the Value added (current US$) in Manufacturing and Value added (current US$) in Agriculture?
Offer a very short reply. -1.29e+08. In the year 2010, what is the difference between the Value added (current US$) of Services and Value added (current US$) of Agriculture?
Keep it short and to the point. 2.11e+09. In the year 2011, what is the difference between the Value added (current US$) of Industry and Value added (current US$) of Manufacturing?
Ensure brevity in your answer.  4.59e+08. In the year 2011, what is the difference between the Value added (current US$) of Industry and Value added (current US$) of Services?
Offer a terse response. -2.07e+09. In the year 2011, what is the difference between the Value added (current US$) in Industry and Value added (current US$) in Agriculture?
Provide a succinct answer. 3.19e+08. In the year 2011, what is the difference between the Value added (current US$) in Manufacturing and Value added (current US$) in Services?
Offer a very short reply. -2.53e+09. In the year 2011, what is the difference between the Value added (current US$) in Manufacturing and Value added (current US$) in Agriculture?
Provide a succinct answer. -1.41e+08. In the year 2011, what is the difference between the Value added (current US$) in Services and Value added (current US$) in Agriculture?
Your response must be concise. 2.38e+09. In the year 2012, what is the difference between the Value added (current US$) in Industry and Value added (current US$) in Manufacturing?
Keep it short and to the point. 4.42e+08. In the year 2012, what is the difference between the Value added (current US$) of Industry and Value added (current US$) of Services?
Keep it short and to the point. -1.91e+09. In the year 2012, what is the difference between the Value added (current US$) in Industry and Value added (current US$) in Agriculture?
Your answer should be compact. 3.04e+08. In the year 2012, what is the difference between the Value added (current US$) of Manufacturing and Value added (current US$) of Services?
Keep it short and to the point. -2.35e+09. In the year 2012, what is the difference between the Value added (current US$) of Manufacturing and Value added (current US$) of Agriculture?
Give a very brief answer. -1.38e+08. In the year 2012, what is the difference between the Value added (current US$) of Services and Value added (current US$) of Agriculture?
Give a very brief answer. 2.21e+09. In the year 2013, what is the difference between the Value added (current US$) of Industry and Value added (current US$) of Manufacturing?
Your response must be concise. 5.10e+08. In the year 2013, what is the difference between the Value added (current US$) of Industry and Value added (current US$) of Services?
Give a very brief answer. -1.92e+09. In the year 2013, what is the difference between the Value added (current US$) of Industry and Value added (current US$) of Agriculture?
Your answer should be compact. 3.31e+08. In the year 2013, what is the difference between the Value added (current US$) in Manufacturing and Value added (current US$) in Services?
Keep it short and to the point. -2.43e+09. In the year 2013, what is the difference between the Value added (current US$) in Manufacturing and Value added (current US$) in Agriculture?
Ensure brevity in your answer.  -1.78e+08. In the year 2013, what is the difference between the Value added (current US$) in Services and Value added (current US$) in Agriculture?
Give a very brief answer. 2.26e+09. In the year 2014, what is the difference between the Value added (current US$) of Industry and Value added (current US$) of Manufacturing?
Keep it short and to the point. 4.78e+08. In the year 2014, what is the difference between the Value added (current US$) of Industry and Value added (current US$) of Services?
Make the answer very short. -2.03e+09. In the year 2014, what is the difference between the Value added (current US$) of Industry and Value added (current US$) of Agriculture?
Your response must be concise. 2.85e+08. In the year 2014, what is the difference between the Value added (current US$) in Manufacturing and Value added (current US$) in Services?
Provide a succinct answer. -2.51e+09. In the year 2014, what is the difference between the Value added (current US$) of Manufacturing and Value added (current US$) of Agriculture?
Offer a very short reply. -1.94e+08. In the year 2014, what is the difference between the Value added (current US$) of Services and Value added (current US$) of Agriculture?
Provide a succinct answer. 2.31e+09. What is the ratio of the Value added (current US$) in Industry in 2008 to that in 2009?
Your answer should be compact. 1.11. What is the ratio of the Value added (current US$) in Manufacturing in 2008 to that in 2009?
Provide a short and direct response. 1.2. What is the ratio of the Value added (current US$) of Services in 2008 to that in 2009?
Provide a short and direct response. 1.05. What is the ratio of the Value added (current US$) of Agriculture in 2008 to that in 2009?
Offer a terse response. 0.98. What is the ratio of the Value added (current US$) in Industry in 2008 to that in 2010?
Keep it short and to the point. 1.08. What is the ratio of the Value added (current US$) of Manufacturing in 2008 to that in 2010?
Provide a short and direct response. 1.29. What is the ratio of the Value added (current US$) of Services in 2008 to that in 2010?
Give a very brief answer. 1.04. What is the ratio of the Value added (current US$) in Agriculture in 2008 to that in 2010?
Keep it short and to the point. 1.06. What is the ratio of the Value added (current US$) in Industry in 2008 to that in 2011?
Provide a short and direct response. 1.12. What is the ratio of the Value added (current US$) of Manufacturing in 2008 to that in 2011?
Ensure brevity in your answer.  1.08. What is the ratio of the Value added (current US$) of Services in 2008 to that in 2011?
Give a very brief answer. 0.92. What is the ratio of the Value added (current US$) in Agriculture in 2008 to that in 2011?
Provide a succinct answer. 0.92. What is the ratio of the Value added (current US$) of Industry in 2008 to that in 2012?
Provide a short and direct response. 1.26. What is the ratio of the Value added (current US$) in Manufacturing in 2008 to that in 2012?
Your answer should be compact. 1.46. What is the ratio of the Value added (current US$) of Agriculture in 2008 to that in 2012?
Make the answer very short. 1.11. What is the ratio of the Value added (current US$) in Industry in 2008 to that in 2013?
Provide a succinct answer. 1.11. What is the ratio of the Value added (current US$) in Manufacturing in 2008 to that in 2013?
Provide a succinct answer. 1.35. What is the ratio of the Value added (current US$) in Services in 2008 to that in 2013?
Your answer should be very brief. 0.96. What is the ratio of the Value added (current US$) in Agriculture in 2008 to that in 2013?
Your answer should be very brief. 0.94. What is the ratio of the Value added (current US$) in Industry in 2008 to that in 2014?
Your response must be concise. 1.17. What is the ratio of the Value added (current US$) of Manufacturing in 2008 to that in 2014?
Your answer should be very brief. 1.37. What is the ratio of the Value added (current US$) in Services in 2008 to that in 2014?
Your answer should be compact. 0.94. What is the ratio of the Value added (current US$) of Agriculture in 2008 to that in 2014?
Offer a terse response. 0.91. What is the ratio of the Value added (current US$) in Industry in 2009 to that in 2010?
Your answer should be compact. 0.97. What is the ratio of the Value added (current US$) in Manufacturing in 2009 to that in 2010?
Ensure brevity in your answer.  1.07. What is the ratio of the Value added (current US$) in Services in 2009 to that in 2010?
Keep it short and to the point. 0.99. What is the ratio of the Value added (current US$) in Agriculture in 2009 to that in 2010?
Your response must be concise. 1.08. What is the ratio of the Value added (current US$) in Industry in 2009 to that in 2011?
Keep it short and to the point. 1.01. What is the ratio of the Value added (current US$) of Manufacturing in 2009 to that in 2011?
Keep it short and to the point. 0.9. What is the ratio of the Value added (current US$) of Services in 2009 to that in 2011?
Provide a short and direct response. 0.87. What is the ratio of the Value added (current US$) of Agriculture in 2009 to that in 2011?
Your answer should be compact. 0.94. What is the ratio of the Value added (current US$) of Industry in 2009 to that in 2012?
Your answer should be compact. 1.13. What is the ratio of the Value added (current US$) of Manufacturing in 2009 to that in 2012?
Provide a short and direct response. 1.22. What is the ratio of the Value added (current US$) in Services in 2009 to that in 2012?
Provide a short and direct response. 0.96. What is the ratio of the Value added (current US$) in Agriculture in 2009 to that in 2012?
Offer a terse response. 1.13. What is the ratio of the Value added (current US$) of Manufacturing in 2009 to that in 2013?
Provide a short and direct response. 1.12. What is the ratio of the Value added (current US$) of Services in 2009 to that in 2013?
Make the answer very short. 0.92. What is the ratio of the Value added (current US$) of Agriculture in 2009 to that in 2013?
Give a very brief answer. 0.96. What is the ratio of the Value added (current US$) of Industry in 2009 to that in 2014?
Your response must be concise. 1.05. What is the ratio of the Value added (current US$) in Manufacturing in 2009 to that in 2014?
Ensure brevity in your answer.  1.14. What is the ratio of the Value added (current US$) of Services in 2009 to that in 2014?
Give a very brief answer. 0.89. What is the ratio of the Value added (current US$) of Agriculture in 2009 to that in 2014?
Your answer should be very brief. 0.92. What is the ratio of the Value added (current US$) in Industry in 2010 to that in 2011?
Give a very brief answer. 1.04. What is the ratio of the Value added (current US$) of Manufacturing in 2010 to that in 2011?
Offer a terse response. 0.84. What is the ratio of the Value added (current US$) in Services in 2010 to that in 2011?
Provide a succinct answer. 0.88. What is the ratio of the Value added (current US$) of Agriculture in 2010 to that in 2011?
Keep it short and to the point. 0.87. What is the ratio of the Value added (current US$) of Industry in 2010 to that in 2012?
Provide a short and direct response. 1.17. What is the ratio of the Value added (current US$) of Manufacturing in 2010 to that in 2012?
Offer a terse response. 1.13. What is the ratio of the Value added (current US$) in Services in 2010 to that in 2012?
Offer a very short reply. 0.97. What is the ratio of the Value added (current US$) of Agriculture in 2010 to that in 2012?
Keep it short and to the point. 1.04. What is the ratio of the Value added (current US$) of Industry in 2010 to that in 2013?
Provide a succinct answer. 1.03. What is the ratio of the Value added (current US$) of Manufacturing in 2010 to that in 2013?
Give a very brief answer. 1.04. What is the ratio of the Value added (current US$) of Services in 2010 to that in 2013?
Your response must be concise. 0.93. What is the ratio of the Value added (current US$) of Agriculture in 2010 to that in 2013?
Make the answer very short. 0.89. What is the ratio of the Value added (current US$) of Industry in 2010 to that in 2014?
Give a very brief answer. 1.08. What is the ratio of the Value added (current US$) in Manufacturing in 2010 to that in 2014?
Offer a very short reply. 1.06. What is the ratio of the Value added (current US$) of Services in 2010 to that in 2014?
Provide a short and direct response. 0.9. What is the ratio of the Value added (current US$) in Agriculture in 2010 to that in 2014?
Offer a terse response. 0.86. What is the ratio of the Value added (current US$) of Industry in 2011 to that in 2012?
Provide a succinct answer. 1.13. What is the ratio of the Value added (current US$) in Manufacturing in 2011 to that in 2012?
Ensure brevity in your answer.  1.35. What is the ratio of the Value added (current US$) of Services in 2011 to that in 2012?
Your answer should be very brief. 1.09. What is the ratio of the Value added (current US$) of Agriculture in 2011 to that in 2012?
Offer a very short reply. 1.2. What is the ratio of the Value added (current US$) of Manufacturing in 2011 to that in 2013?
Ensure brevity in your answer.  1.25. What is the ratio of the Value added (current US$) in Services in 2011 to that in 2013?
Provide a succinct answer. 1.05. What is the ratio of the Value added (current US$) of Agriculture in 2011 to that in 2013?
Make the answer very short. 1.02. What is the ratio of the Value added (current US$) of Industry in 2011 to that in 2014?
Provide a short and direct response. 1.04. What is the ratio of the Value added (current US$) of Manufacturing in 2011 to that in 2014?
Make the answer very short. 1.27. What is the ratio of the Value added (current US$) of Agriculture in 2011 to that in 2014?
Make the answer very short. 0.99. What is the ratio of the Value added (current US$) of Industry in 2012 to that in 2013?
Offer a terse response. 0.88. What is the ratio of the Value added (current US$) in Manufacturing in 2012 to that in 2013?
Make the answer very short. 0.92. What is the ratio of the Value added (current US$) in Services in 2012 to that in 2013?
Provide a short and direct response. 0.96. What is the ratio of the Value added (current US$) in Agriculture in 2012 to that in 2013?
Offer a very short reply. 0.85. What is the ratio of the Value added (current US$) in Industry in 2012 to that in 2014?
Your answer should be very brief. 0.93. What is the ratio of the Value added (current US$) of Manufacturing in 2012 to that in 2014?
Offer a terse response. 0.94. What is the ratio of the Value added (current US$) of Services in 2012 to that in 2014?
Provide a succinct answer. 0.94. What is the ratio of the Value added (current US$) of Agriculture in 2012 to that in 2014?
Your response must be concise. 0.82. What is the ratio of the Value added (current US$) of Industry in 2013 to that in 2014?
Make the answer very short. 1.05. What is the ratio of the Value added (current US$) in Manufacturing in 2013 to that in 2014?
Make the answer very short. 1.01. What is the ratio of the Value added (current US$) of Services in 2013 to that in 2014?
Your answer should be very brief. 0.97. What is the ratio of the Value added (current US$) of Agriculture in 2013 to that in 2014?
Your answer should be very brief. 0.97. What is the difference between the highest and the second highest Value added (current US$) in Industry?
Keep it short and to the point. 5.74e+07. What is the difference between the highest and the second highest Value added (current US$) of Manufacturing?
Give a very brief answer. 1.82e+07. What is the difference between the highest and the second highest Value added (current US$) in Services?
Your response must be concise. 6.45e+07. What is the difference between the highest and the second highest Value added (current US$) of Agriculture?
Offer a very short reply. 5.25e+06. What is the difference between the highest and the lowest Value added (current US$) of Industry?
Make the answer very short. 1.59e+08. What is the difference between the highest and the lowest Value added (current US$) of Manufacturing?
Give a very brief answer. 7.72e+07. What is the difference between the highest and the lowest Value added (current US$) of Services?
Offer a very short reply. 3.49e+08. What is the difference between the highest and the lowest Value added (current US$) in Agriculture?
Give a very brief answer. 6.70e+07. 